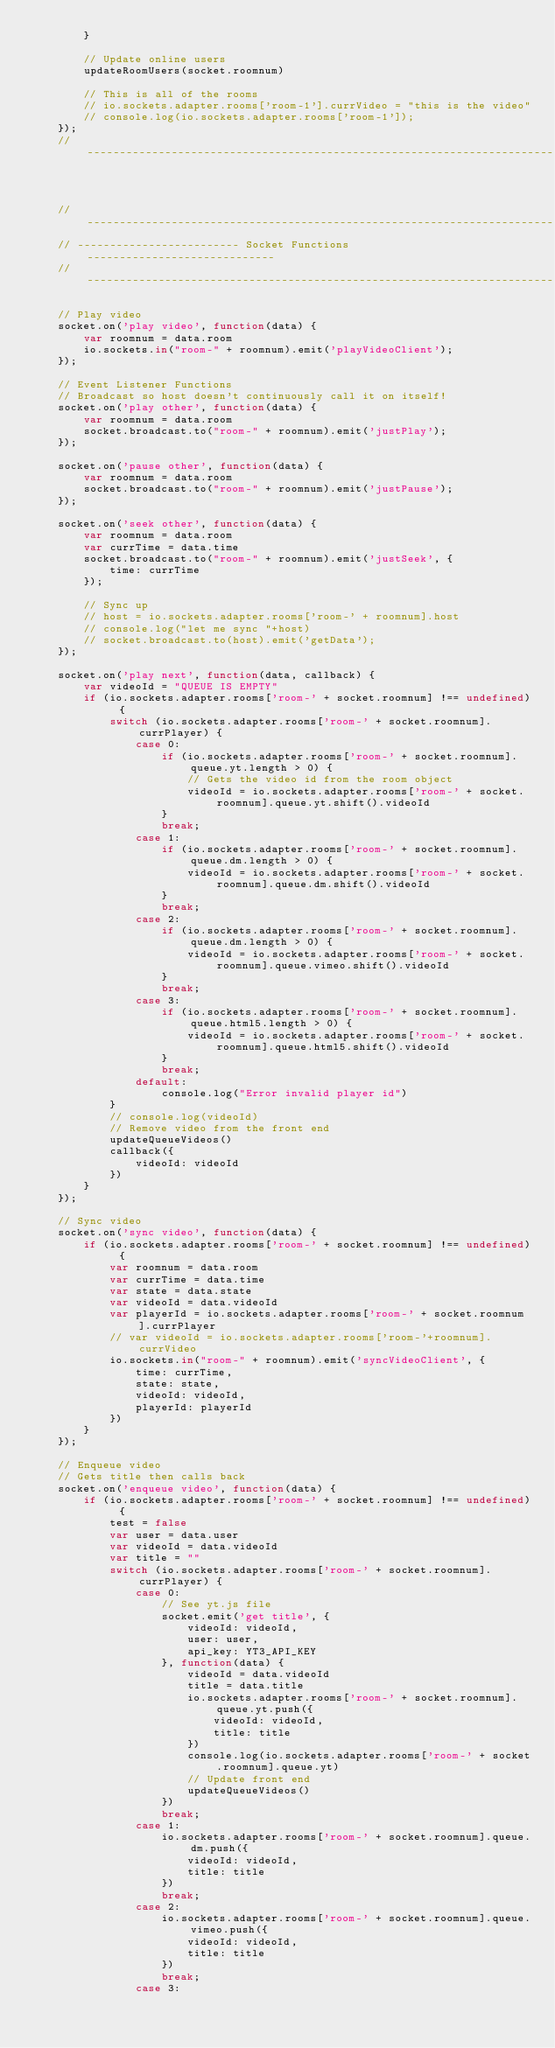Convert code to text. <code><loc_0><loc_0><loc_500><loc_500><_JavaScript_>        }

        // Update online users
        updateRoomUsers(socket.roomnum)

        // This is all of the rooms
        // io.sockets.adapter.rooms['room-1'].currVideo = "this is the video"
        // console.log(io.sockets.adapter.rooms['room-1']);
    });
    // ------------------------------------------------------------------------



    // ------------------------------------------------------------------------
    // ------------------------- Socket Functions -----------------------------
    // ------------------------------------------------------------------------

    // Play video
    socket.on('play video', function(data) {
        var roomnum = data.room
        io.sockets.in("room-" + roomnum).emit('playVideoClient');
    });

    // Event Listener Functions
    // Broadcast so host doesn't continuously call it on itself!
    socket.on('play other', function(data) {
        var roomnum = data.room
        socket.broadcast.to("room-" + roomnum).emit('justPlay');
    });

    socket.on('pause other', function(data) {
        var roomnum = data.room
        socket.broadcast.to("room-" + roomnum).emit('justPause');
    });

    socket.on('seek other', function(data) {
        var roomnum = data.room
        var currTime = data.time
        socket.broadcast.to("room-" + roomnum).emit('justSeek', {
            time: currTime
        });

        // Sync up
        // host = io.sockets.adapter.rooms['room-' + roomnum].host
        // console.log("let me sync "+host)
        // socket.broadcast.to(host).emit('getData');
    });

    socket.on('play next', function(data, callback) {
        var videoId = "QUEUE IS EMPTY"
        if (io.sockets.adapter.rooms['room-' + socket.roomnum] !== undefined) {
            switch (io.sockets.adapter.rooms['room-' + socket.roomnum].currPlayer) {
                case 0:
                    if (io.sockets.adapter.rooms['room-' + socket.roomnum].queue.yt.length > 0) {
                        // Gets the video id from the room object
                        videoId = io.sockets.adapter.rooms['room-' + socket.roomnum].queue.yt.shift().videoId
                    }
                    break;
                case 1:
                    if (io.sockets.adapter.rooms['room-' + socket.roomnum].queue.dm.length > 0) {
                        videoId = io.sockets.adapter.rooms['room-' + socket.roomnum].queue.dm.shift().videoId
                    }
                    break;
                case 2:
                    if (io.sockets.adapter.rooms['room-' + socket.roomnum].queue.dm.length > 0) {
                        videoId = io.sockets.adapter.rooms['room-' + socket.roomnum].queue.vimeo.shift().videoId
                    }
                    break;
                case 3:
                    if (io.sockets.adapter.rooms['room-' + socket.roomnum].queue.html5.length > 0) {
                        videoId = io.sockets.adapter.rooms['room-' + socket.roomnum].queue.html5.shift().videoId
                    }
                    break;
                default:
                    console.log("Error invalid player id")
            }
            // console.log(videoId)
            // Remove video from the front end
            updateQueueVideos()
            callback({
                videoId: videoId
            })
        }
    });

    // Sync video
    socket.on('sync video', function(data) {
        if (io.sockets.adapter.rooms['room-' + socket.roomnum] !== undefined) {
            var roomnum = data.room
            var currTime = data.time
            var state = data.state
            var videoId = data.videoId
            var playerId = io.sockets.adapter.rooms['room-' + socket.roomnum].currPlayer
            // var videoId = io.sockets.adapter.rooms['room-'+roomnum].currVideo
            io.sockets.in("room-" + roomnum).emit('syncVideoClient', {
                time: currTime,
                state: state,
                videoId: videoId,
                playerId: playerId
            })
        }
    });

    // Enqueue video
    // Gets title then calls back
    socket.on('enqueue video', function(data) {
        if (io.sockets.adapter.rooms['room-' + socket.roomnum] !== undefined) {
            test = false
            var user = data.user
            var videoId = data.videoId
            var title = ""
            switch (io.sockets.adapter.rooms['room-' + socket.roomnum].currPlayer) {
                case 0:
                    // See yt.js file
                    socket.emit('get title', {
                        videoId: videoId,
                        user: user,
                        api_key: YT3_API_KEY
                    }, function(data) {
                        videoId = data.videoId
                        title = data.title
                        io.sockets.adapter.rooms['room-' + socket.roomnum].queue.yt.push({
                            videoId: videoId,
                            title: title
                        })
                        console.log(io.sockets.adapter.rooms['room-' + socket.roomnum].queue.yt)
                        // Update front end
                        updateQueueVideos()
                    })
                    break;
                case 1:
                    io.sockets.adapter.rooms['room-' + socket.roomnum].queue.dm.push({
                        videoId: videoId,
                        title: title
                    })
                    break;
                case 2:
                    io.sockets.adapter.rooms['room-' + socket.roomnum].queue.vimeo.push({
                        videoId: videoId,
                        title: title
                    })
                    break;
                case 3:</code> 